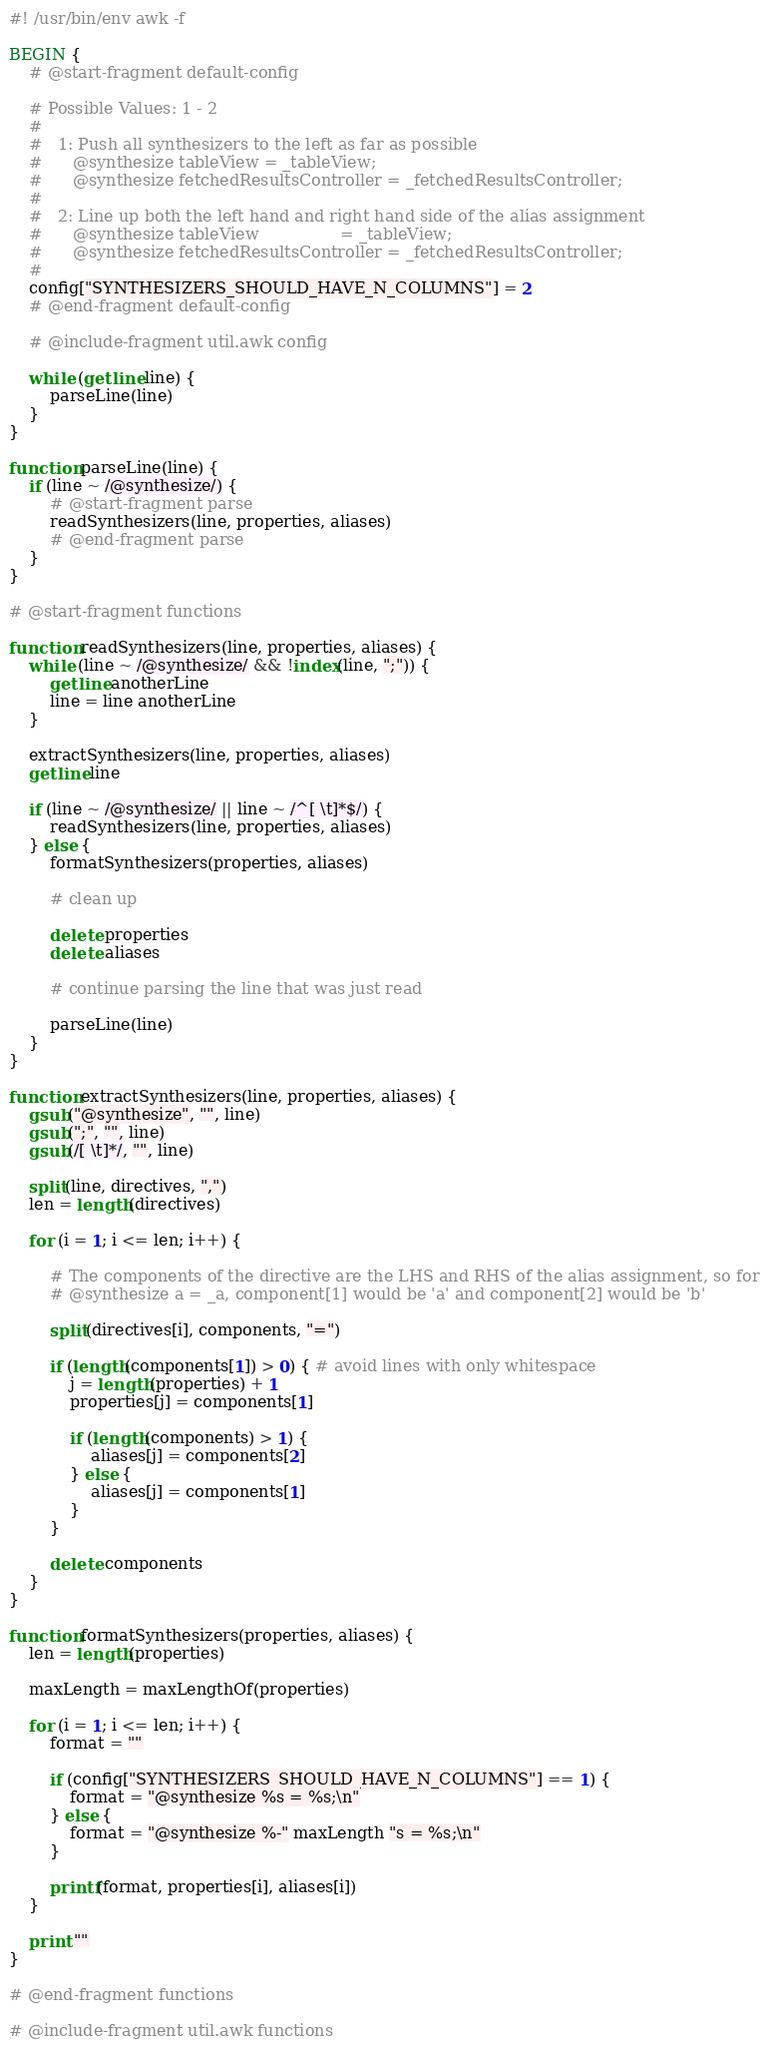Convert code to text. <code><loc_0><loc_0><loc_500><loc_500><_Awk_>#! /usr/bin/env awk -f

BEGIN {
	# @start-fragment default-config

	# Possible Values: 1 - 2
	#
	#   1: Push all synthesizers to the left as far as possible
	#      @synthesize tableView = _tableView;
	#      @synthesize fetchedResultsController = _fetchedResultsController;
	#
	#   2: Line up both the left hand and right hand side of the alias assignment
	#      @synthesize tableView                = _tableView;
	#      @synthesize fetchedResultsController = _fetchedResultsController;
	#
	config["SYNTHESIZERS_SHOULD_HAVE_N_COLUMNS"] = 2
	# @end-fragment default-config

	# @include-fragment util.awk config

	while (getline line) {
		parseLine(line)
	}
}

function parseLine(line) {
	if (line ~ /@synthesize/) {
		# @start-fragment parse
		readSynthesizers(line, properties, aliases)
		# @end-fragment parse
	}
}

# @start-fragment functions

function readSynthesizers(line, properties, aliases) {
	while (line ~ /@synthesize/ && !index(line, ";")) {
		getline anotherLine
		line = line anotherLine
	}

	extractSynthesizers(line, properties, aliases)
	getline line

	if (line ~ /@synthesize/ || line ~ /^[ \t]*$/) {
		readSynthesizers(line, properties, aliases)
	} else {
		formatSynthesizers(properties, aliases)
		
		# clean up
		
		delete properties
		delete aliases
		
		# continue parsing the line that was just read
		
		parseLine(line)
	}
}

function extractSynthesizers(line, properties, aliases) {
	gsub("@synthesize", "", line)
	gsub(";", "", line)
	gsub(/[ \t]*/, "", line)

	split(line, directives, ",")
	len = length(directives)

	for (i = 1; i <= len; i++) {

		# The components of the directive are the LHS and RHS of the alias assignment, so for
		# @synthesize a = _a, component[1] would be 'a' and component[2] would be 'b'

		split(directives[i], components, "=")

		if (length(components[1]) > 0) { # avoid lines with only whitespace
			j = length(properties) + 1
			properties[j] = components[1]

			if (length(components) > 1) {
				aliases[j] = components[2]
			} else {
				aliases[j] = components[1]
			}
		}
		
		delete components
	}
}

function formatSynthesizers(properties, aliases) {
	len = length(properties)

	maxLength = maxLengthOf(properties)

	for (i = 1; i <= len; i++) {
		format = ""

		if (config["SYNTHESIZERS_SHOULD_HAVE_N_COLUMNS"] == 1) {
			format = "@synthesize %s = %s;\n"
		} else {
			format = "@synthesize %-" maxLength "s = %s;\n"
		}

		printf(format, properties[i], aliases[i])
	}

	print ""
}

# @end-fragment functions

# @include-fragment util.awk functions</code> 